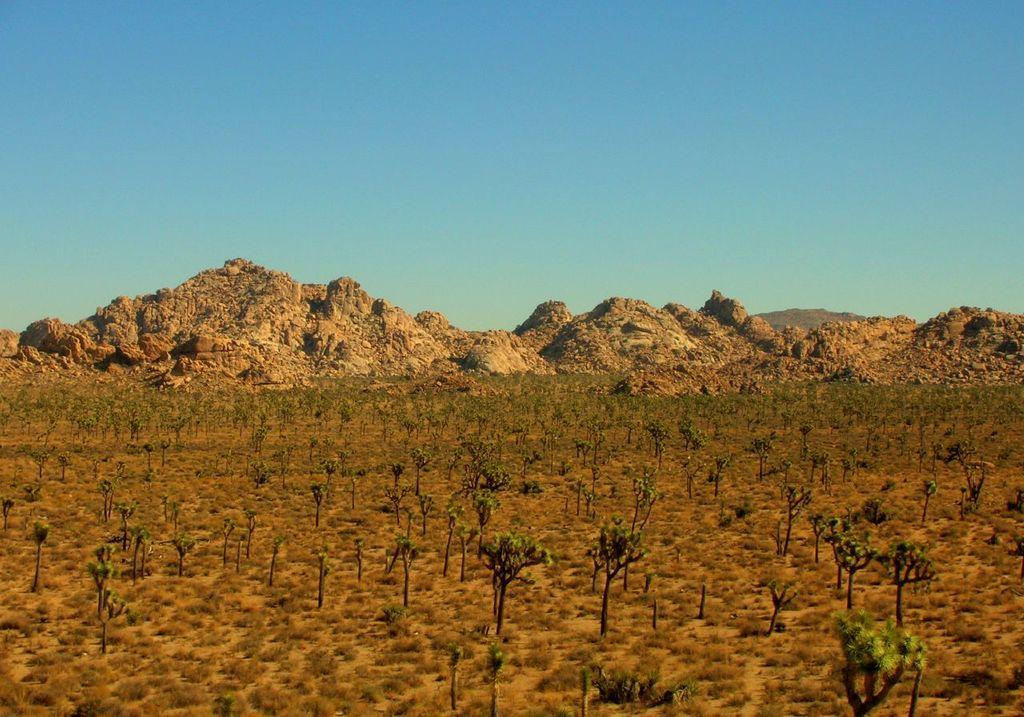What type of vegetation can be seen in the image? There are plants and grass visible in the image. What is the ground like in the image? The ground is visible in the image. What type of landscape feature is present in the image? There are mountains in the image. What is the condition of the sky in the background of the image? The sky is clear in the background of the image. What type of journey can be seen in the image? There is no journey visible in the image; it is a still scene featuring plants, grass, mountains, and a clear sky. How does the image show care for the environment? The image itself does not demonstrate care for the environment, as it is a static representation of a landscape. 